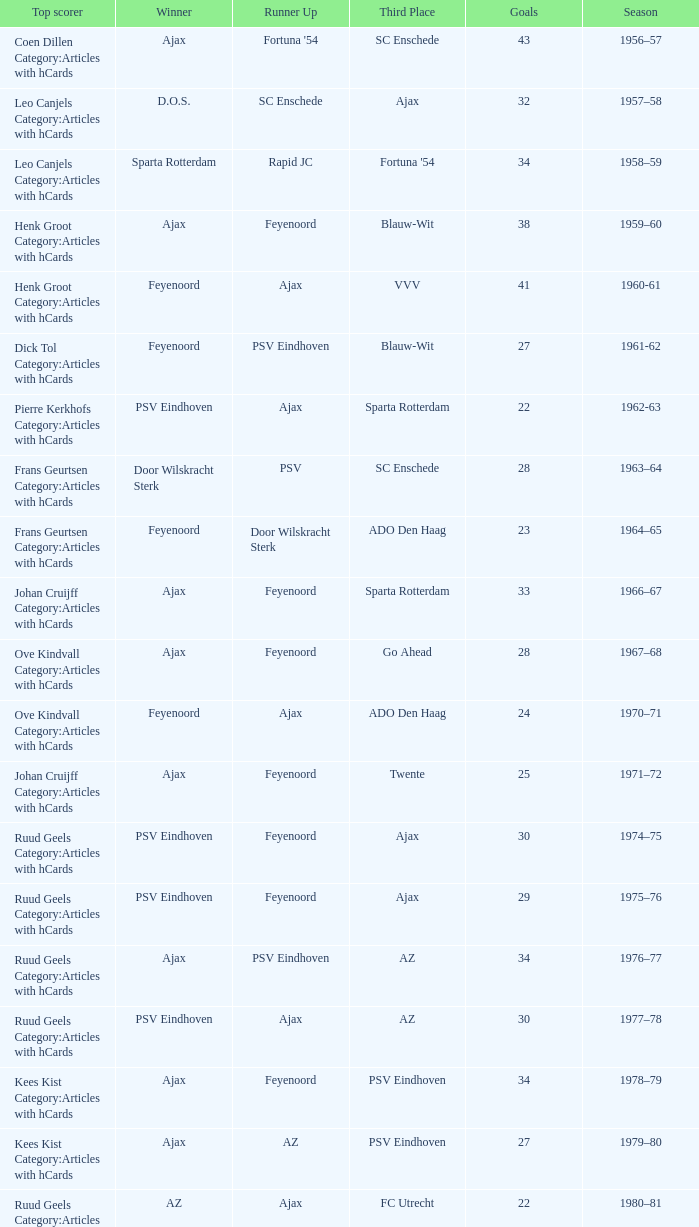When nac breda came in third place and psv eindhoven was the winner who is the top scorer? Klaas-Jan Huntelaar Category:Articles with hCards. 